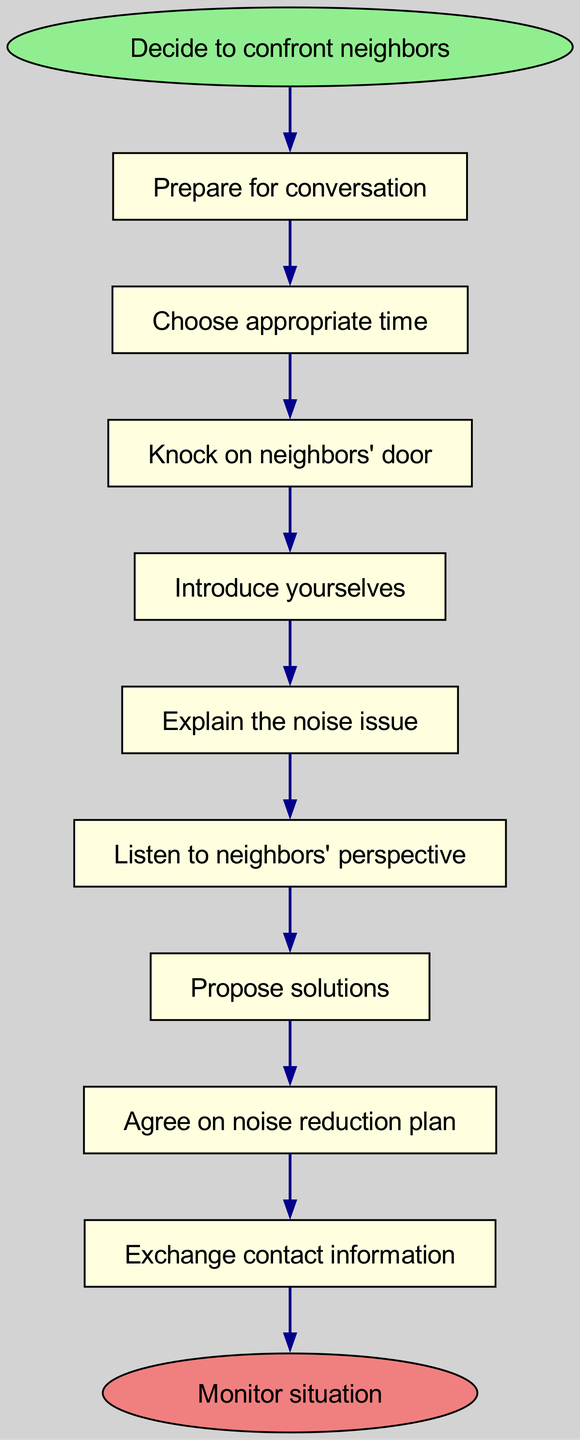What is the first action to take when confronting neighbors? The diagram indicates that the first action after deciding to confront neighbors is "Prepare for conversation." This shows a clear sequence starting with preparation before any other steps.
Answer: Prepare for conversation How many actions are listed in the diagram? By counting the individual actions outlined in the diagram, we find there are nine actions mentioned in the flow of the confrontation process, excluding the start and end.
Answer: Nine What is the last action before monitoring the situation? The last action listed before reaching the end node "Monitor situation" is "Exchange contact information." This indicates the last step in the negotiation process before observing the changes.
Answer: Exchange contact information What comes after explaining the noise issue? When following the flow, "Listen to neighbors' perspective" directly follows "Explain the noise issue." This step emphasizes the importance of considering the neighbors' viewpoint on the matter.
Answer: Listen to neighbors' perspective If a couple does not prepare for the conversation, what action will they miss? If the couple skips the "Prepare for conversation" step, the next action they would miss is "Choose appropriate time." This highlights the importance of preparation as a precursor to effectively addressing the issue.
Answer: Choose appropriate time What action is directly before agreeing on a noise reduction plan? The immediate action preceding "Agree on noise reduction plan" is "Propose solutions." This shows that proposing solutions is a necessary step that leads to agreement on plans for reducing noise.
Answer: Propose solutions How are the actions connected in the diagram? The actions are connected sequentially from the start through to the end, with each action leading to the next in a linear flow, indicating a clear progression in addressing the noise conflict.
Answer: Sequentially What color represents the end node in the diagram? The end node in the diagram is colored "light coral," distinguishing it visually from other nodes and indicating that it signifies the conclusion of the confrontation process.
Answer: Light coral 